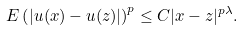Convert formula to latex. <formula><loc_0><loc_0><loc_500><loc_500>E \left ( | u ( x ) - u ( z ) | \right ) ^ { p } \leq C | x - z | ^ { p \lambda } .</formula> 